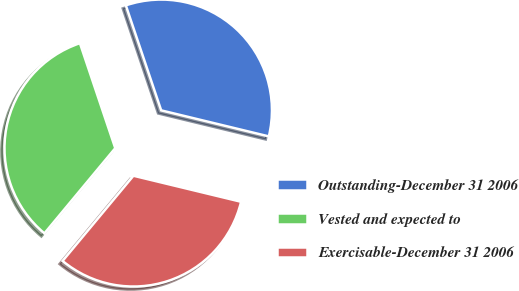Convert chart. <chart><loc_0><loc_0><loc_500><loc_500><pie_chart><fcel>Outstanding-December 31 2006<fcel>Vested and expected to<fcel>Exercisable-December 31 2006<nl><fcel>33.94%<fcel>33.79%<fcel>32.26%<nl></chart> 